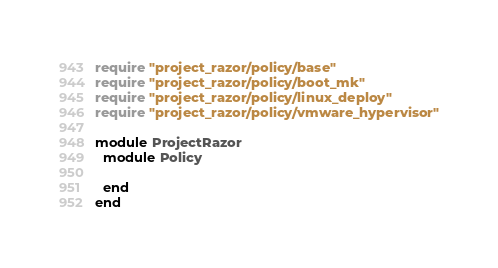<code> <loc_0><loc_0><loc_500><loc_500><_Ruby_>require "project_razor/policy/base"
require "project_razor/policy/boot_mk"
require "project_razor/policy/linux_deploy"
require "project_razor/policy/vmware_hypervisor"

module ProjectRazor
  module Policy

  end
end
</code> 